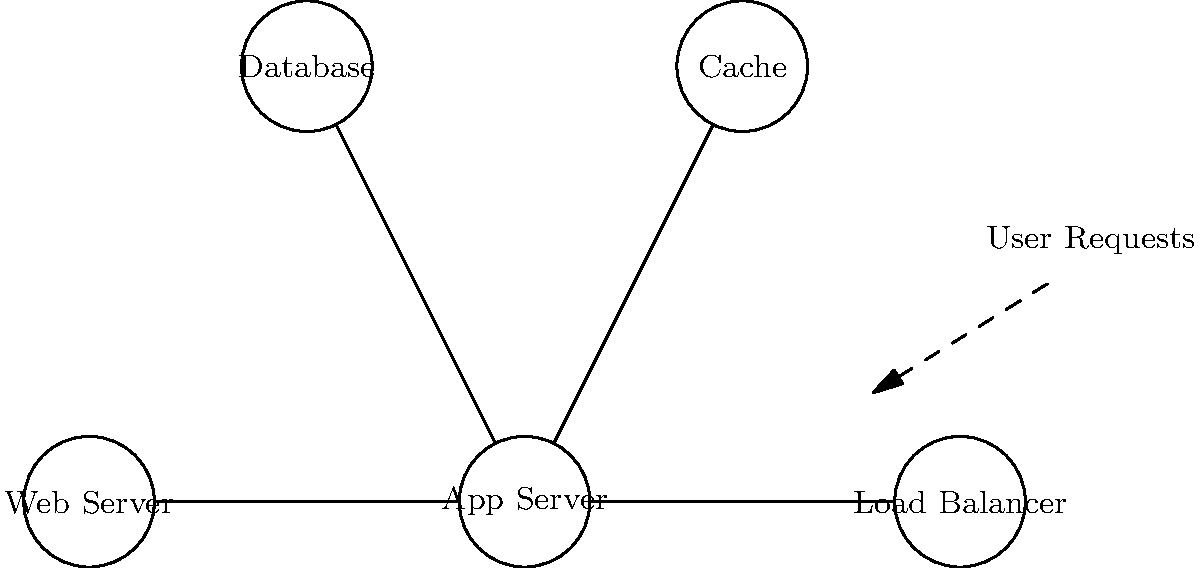In the given system diagram of a web application architecture, what potential bottleneck could cause performance issues if not properly optimized, and how would you address it to improve the overall system efficiency? To identify and address the potential bottleneck in this web application architecture, we need to analyze each component and their interactions:

1. Load Balancer: Distributes incoming traffic, unlikely to be a bottleneck if properly configured.

2. Web Server: Handles initial request processing, could be a bottleneck if unable to handle high concurrent connections.

3. App Server: Processes application logic, potential bottleneck if computationally intensive operations are not optimized.

4. Database: Often the primary bottleneck in database-driven applications due to:
   a) Slow queries
   b) Lack of proper indexing
   c) High read/write operations

5. Cache: Helps alleviate database load, but if not utilized effectively, it won't mitigate the database bottleneck.

The database is the most likely bottleneck in this architecture. To address this:

1. Optimize database queries
2. Implement proper indexing
3. Use database connection pooling
4. Utilize the cache more effectively for frequently accessed data
5. Consider database sharding for horizontal scaling
6. Implement read replicas for distributing read operations

By focusing on database optimization and effective caching, we can significantly improve the overall system efficiency and reduce the potential bottleneck.
Answer: Database optimization and effective caching 